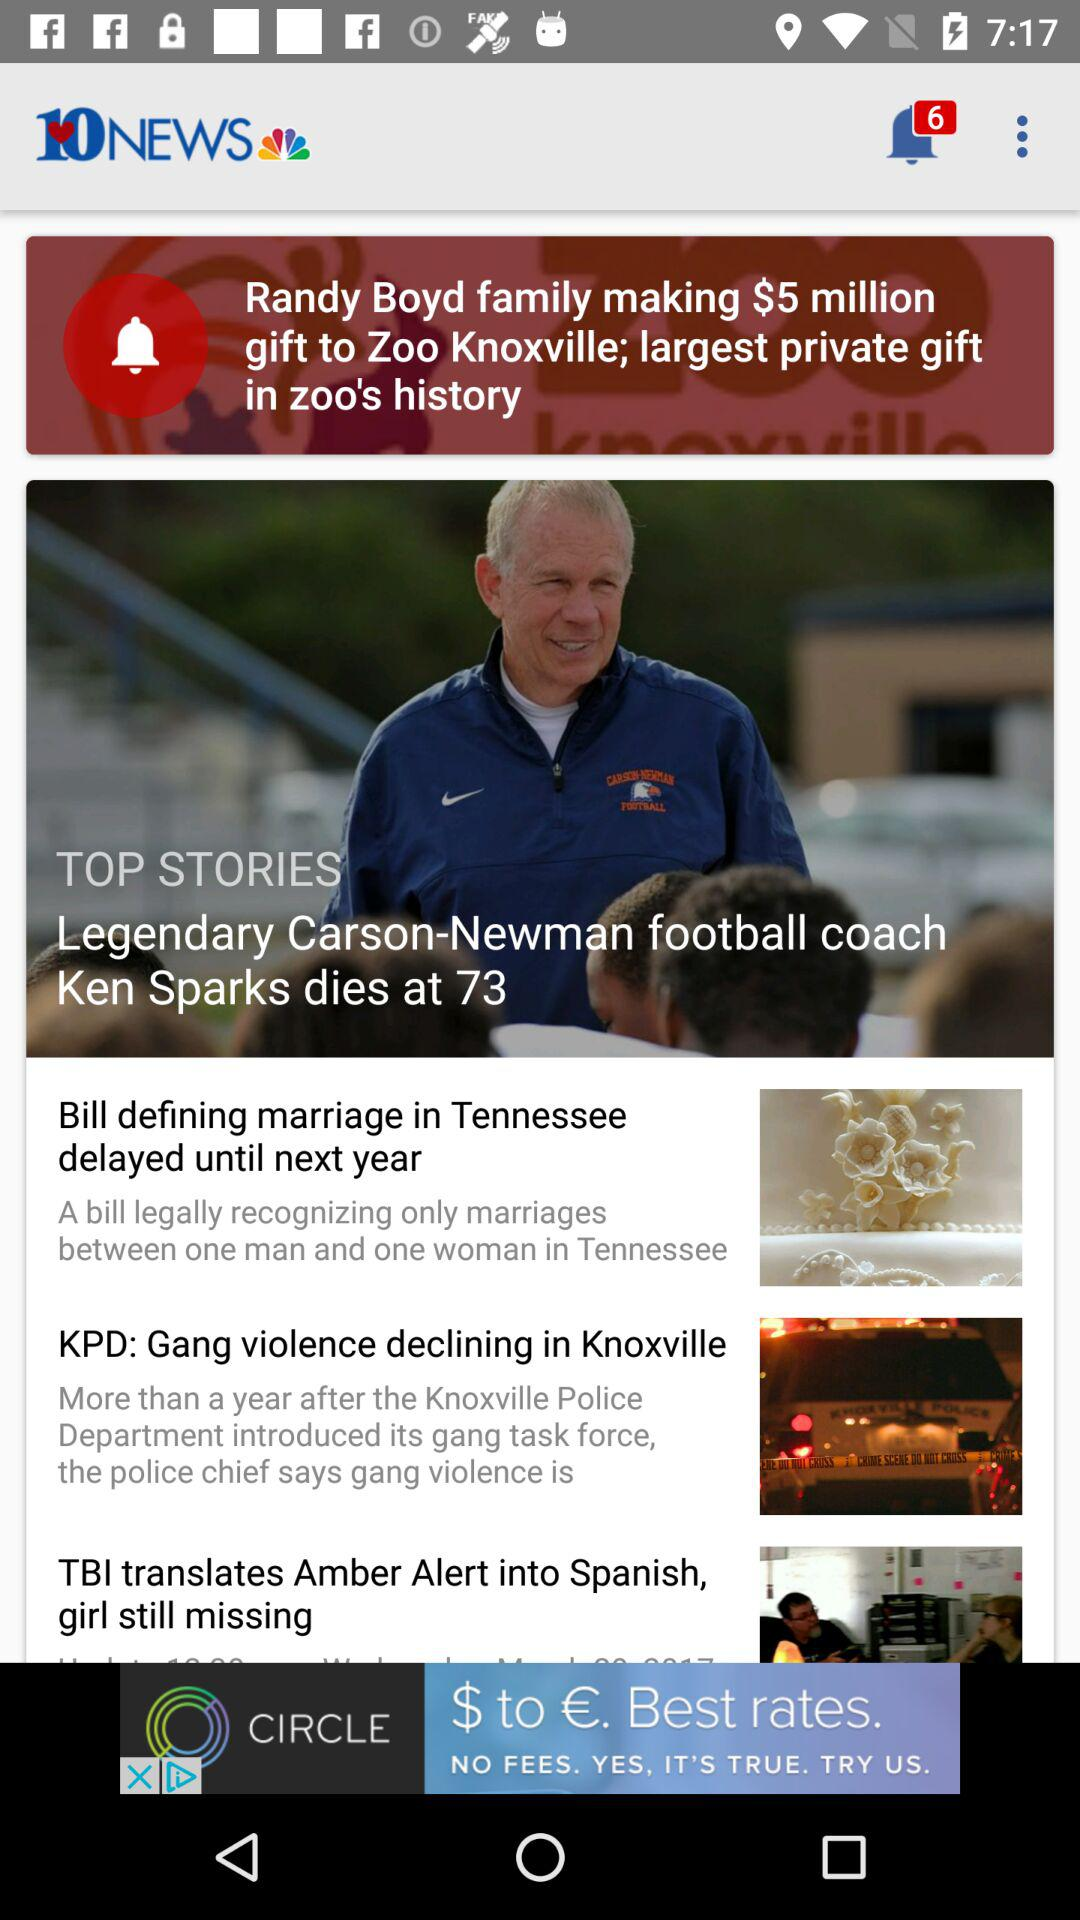How many unread notifications are there? There are 6 unread notifications. 